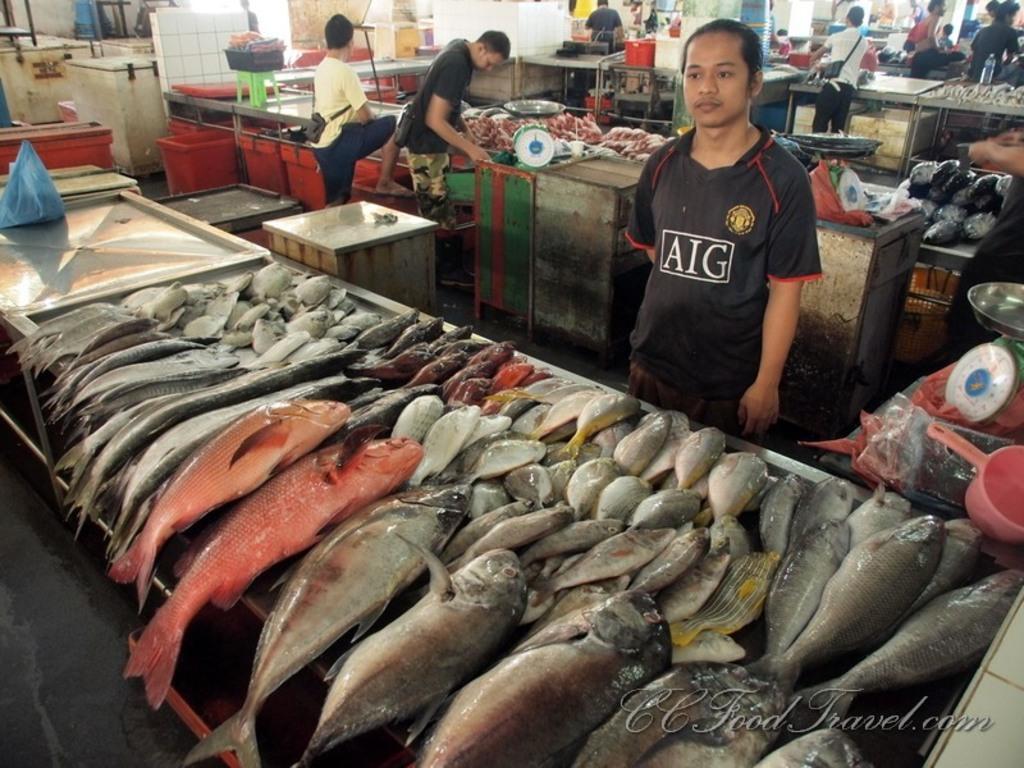In one or two sentences, can you explain what this image depicts? In the picture we can see a fish market with many type of fishes on the table and behind it we can see a man standing with black T-shirt and behind him we can see some tables with fishes and near it we can see two people standing and behind it also we can see some people are standing near the tables. 